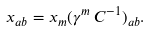<formula> <loc_0><loc_0><loc_500><loc_500>x _ { a b } = x _ { m } ( \gamma ^ { m } \, C ^ { - 1 } ) _ { a b } .</formula> 